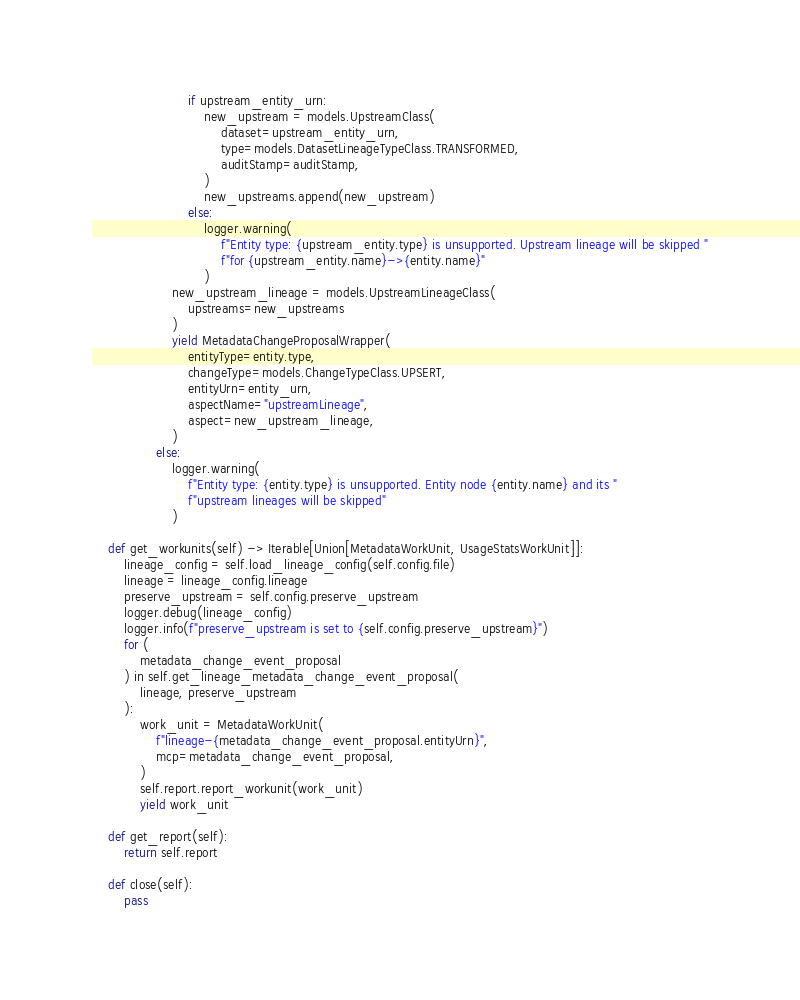Convert code to text. <code><loc_0><loc_0><loc_500><loc_500><_Python_>                        if upstream_entity_urn:
                            new_upstream = models.UpstreamClass(
                                dataset=upstream_entity_urn,
                                type=models.DatasetLineageTypeClass.TRANSFORMED,
                                auditStamp=auditStamp,
                            )
                            new_upstreams.append(new_upstream)
                        else:
                            logger.warning(
                                f"Entity type: {upstream_entity.type} is unsupported. Upstream lineage will be skipped "
                                f"for {upstream_entity.name}->{entity.name}"
                            )
                    new_upstream_lineage = models.UpstreamLineageClass(
                        upstreams=new_upstreams
                    )
                    yield MetadataChangeProposalWrapper(
                        entityType=entity.type,
                        changeType=models.ChangeTypeClass.UPSERT,
                        entityUrn=entity_urn,
                        aspectName="upstreamLineage",
                        aspect=new_upstream_lineage,
                    )
                else:
                    logger.warning(
                        f"Entity type: {entity.type} is unsupported. Entity node {entity.name} and its "
                        f"upstream lineages will be skipped"
                    )

    def get_workunits(self) -> Iterable[Union[MetadataWorkUnit, UsageStatsWorkUnit]]:
        lineage_config = self.load_lineage_config(self.config.file)
        lineage = lineage_config.lineage
        preserve_upstream = self.config.preserve_upstream
        logger.debug(lineage_config)
        logger.info(f"preserve_upstream is set to {self.config.preserve_upstream}")
        for (
            metadata_change_event_proposal
        ) in self.get_lineage_metadata_change_event_proposal(
            lineage, preserve_upstream
        ):
            work_unit = MetadataWorkUnit(
                f"lineage-{metadata_change_event_proposal.entityUrn}",
                mcp=metadata_change_event_proposal,
            )
            self.report.report_workunit(work_unit)
            yield work_unit

    def get_report(self):
        return self.report

    def close(self):
        pass
</code> 